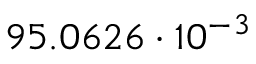Convert formula to latex. <formula><loc_0><loc_0><loc_500><loc_500>9 5 . 0 6 2 6 \cdot 1 0 ^ { - 3 }</formula> 